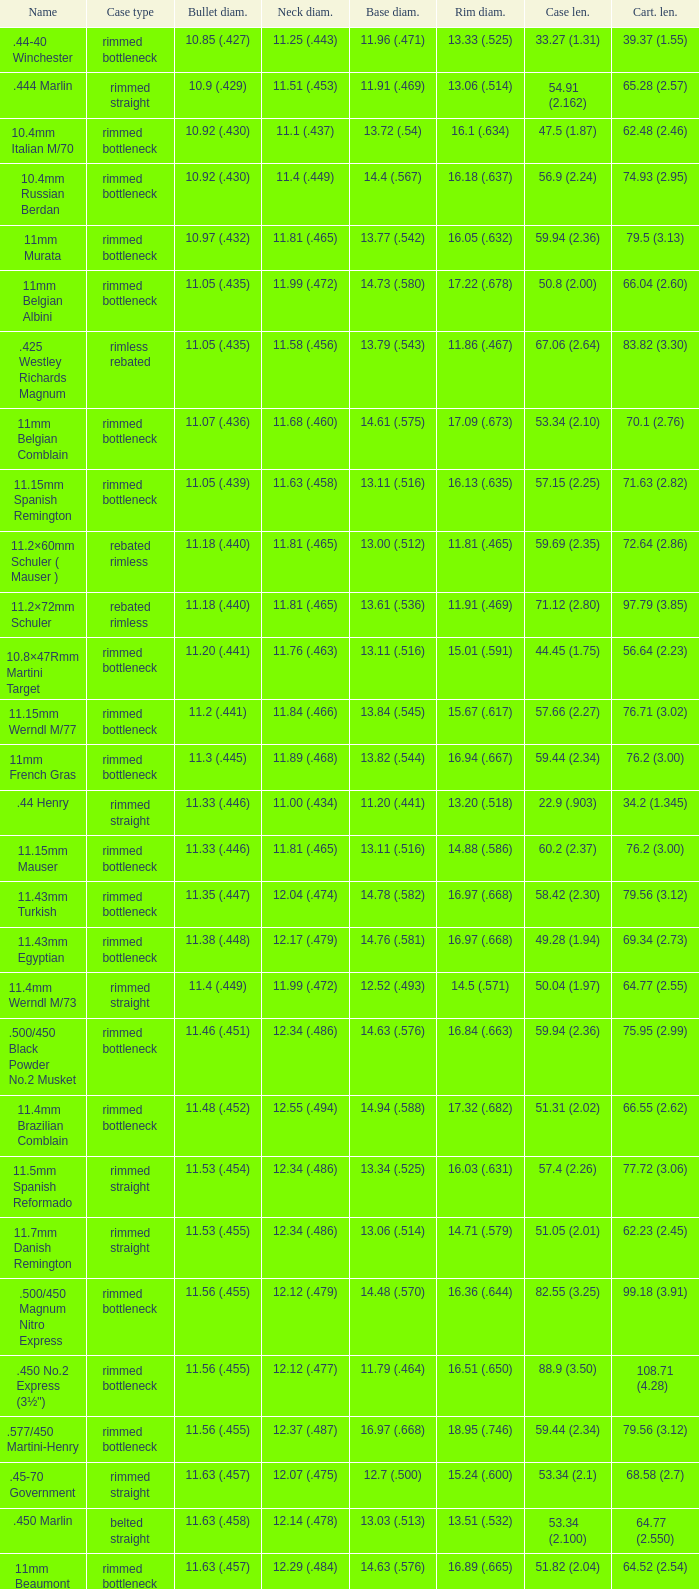Which Case type has a Cartridge length of 64.77 (2.550)? Belted straight. 